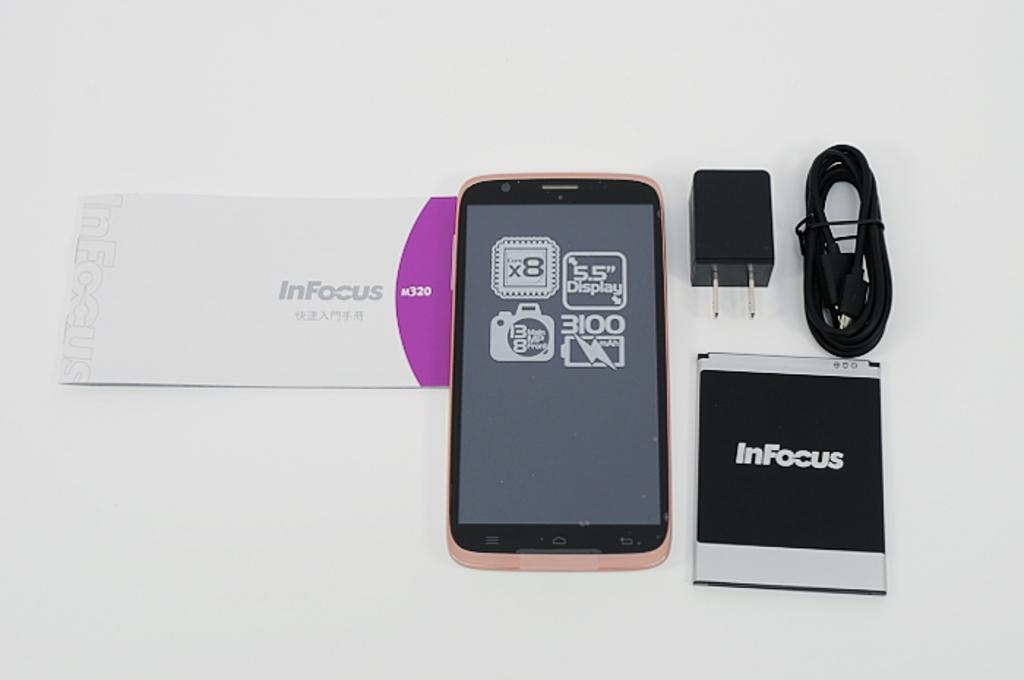<image>
Offer a succinct explanation of the picture presented. An InFocus cellphone and charger lay on a white surface. 